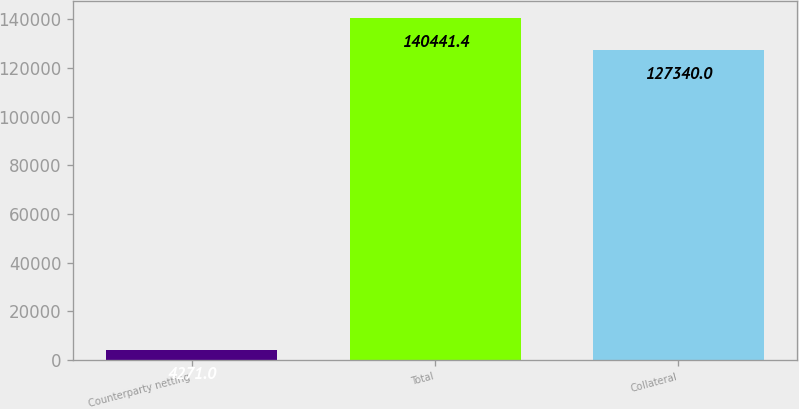Convert chart. <chart><loc_0><loc_0><loc_500><loc_500><bar_chart><fcel>Counterparty netting<fcel>Total<fcel>Collateral<nl><fcel>4271<fcel>140441<fcel>127340<nl></chart> 